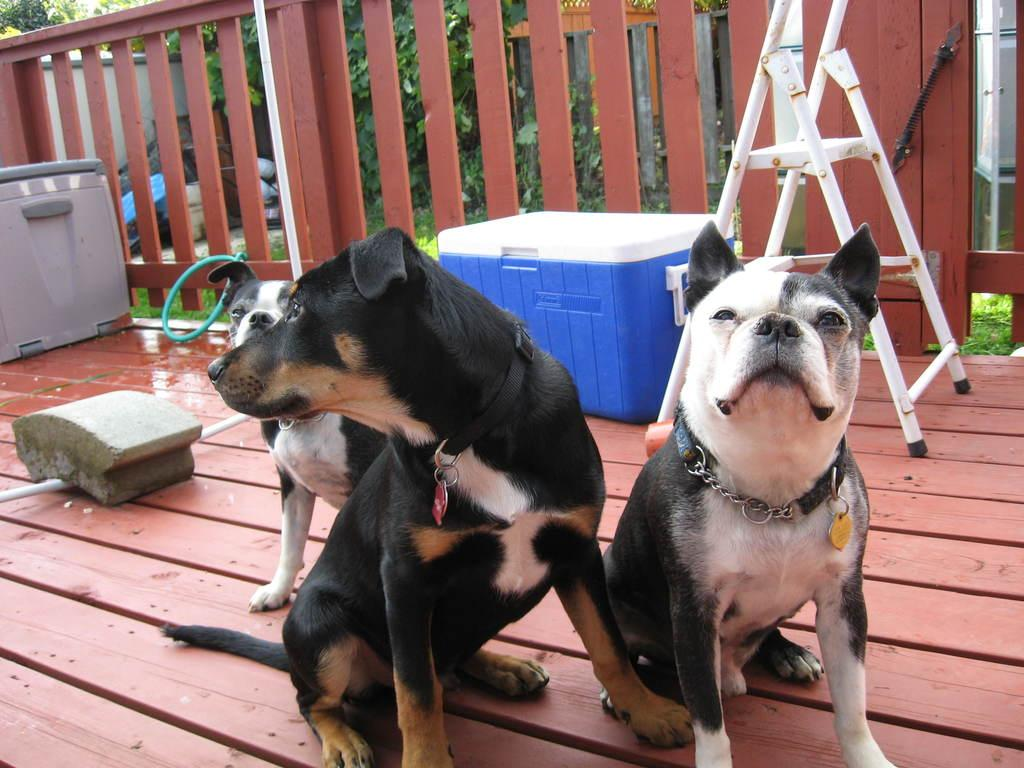What type of animals can be seen in the image? There are dogs in the image. What is the shape or material of the object located near the dogs? There is a stone in the image. What type of man-made structures are present in the image? There are pipes, a ladder, boxes, a fence, and a door in the image. What can be seen in the background of the image? There is a wall, grass, plants, and other objects in the background of the image. What type of oatmeal is being served in the image? There is no oatmeal present in the image. What sound can be heard coming from the cannon in the image? There is no cannon present in the image, so no sound can be heard from it. 